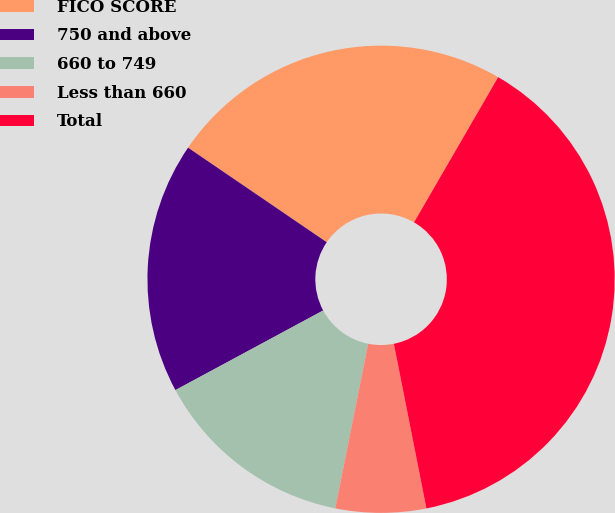<chart> <loc_0><loc_0><loc_500><loc_500><pie_chart><fcel>FICO SCORE<fcel>750 and above<fcel>660 to 749<fcel>Less than 660<fcel>Total<nl><fcel>23.83%<fcel>17.39%<fcel>13.99%<fcel>6.25%<fcel>38.53%<nl></chart> 